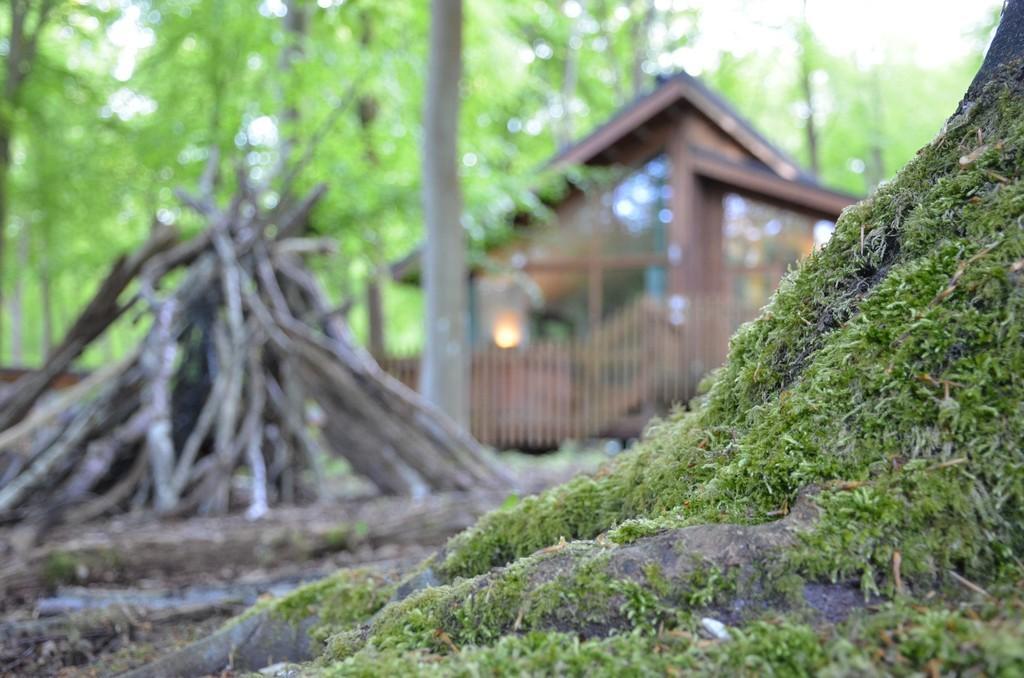Please provide a concise description of this image. This image is clicked outside. At the bottom, we can see the grass on the root of a tree. On the left, there are wooden stick. In the background, we can see a house and many trees. 